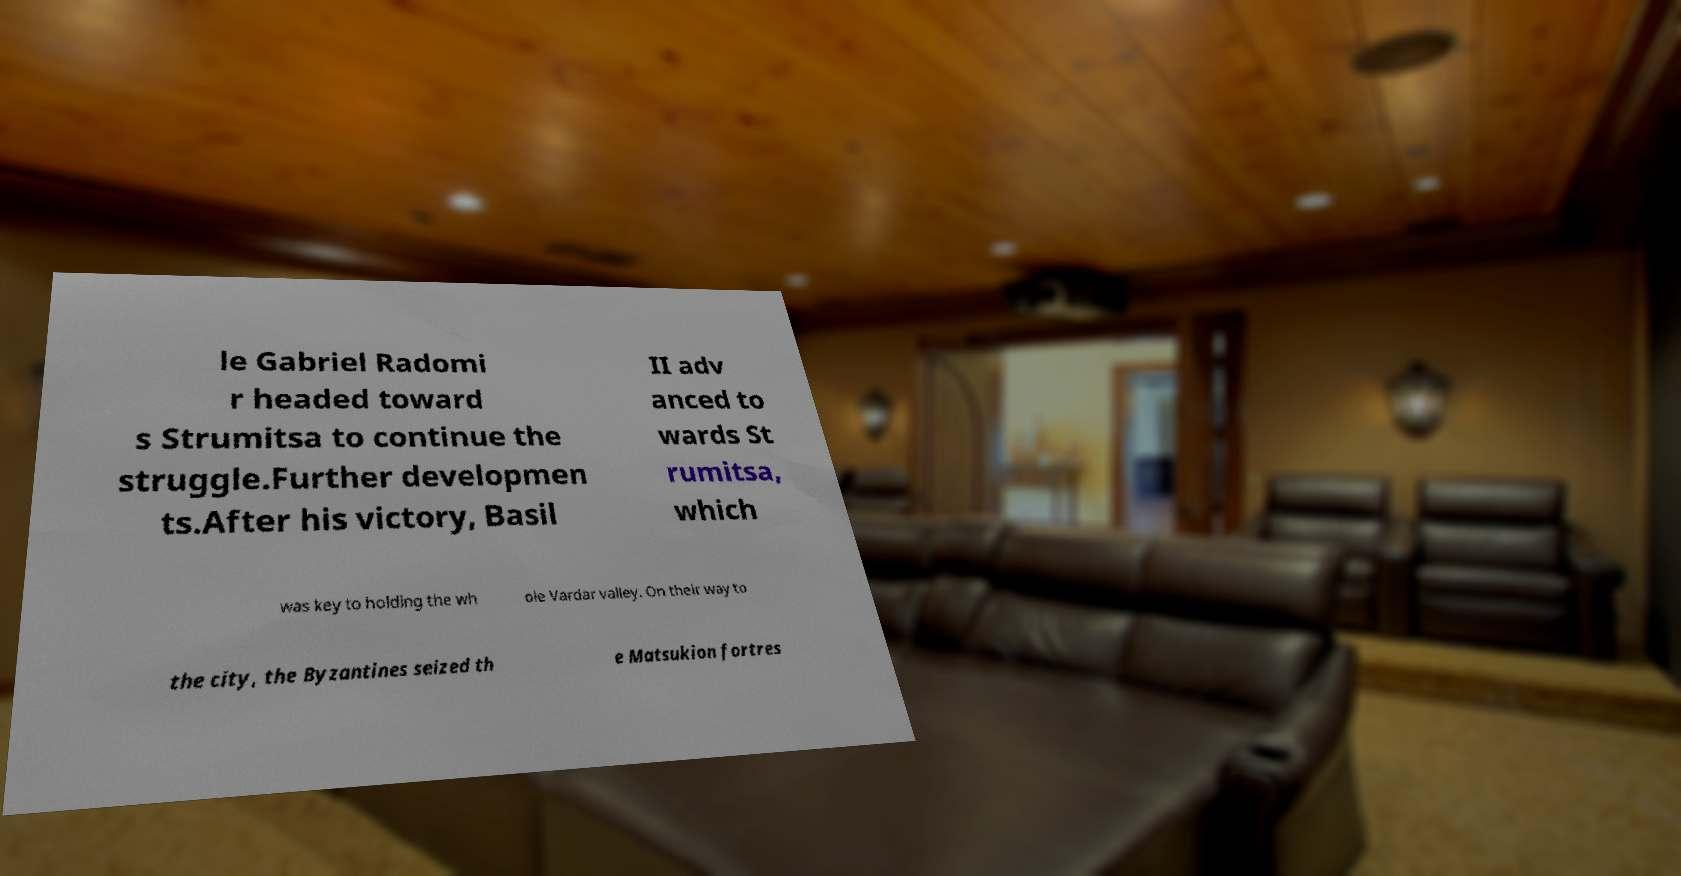Can you read and provide the text displayed in the image?This photo seems to have some interesting text. Can you extract and type it out for me? le Gabriel Radomi r headed toward s Strumitsa to continue the struggle.Further developmen ts.After his victory, Basil II adv anced to wards St rumitsa, which was key to holding the wh ole Vardar valley. On their way to the city, the Byzantines seized th e Matsukion fortres 